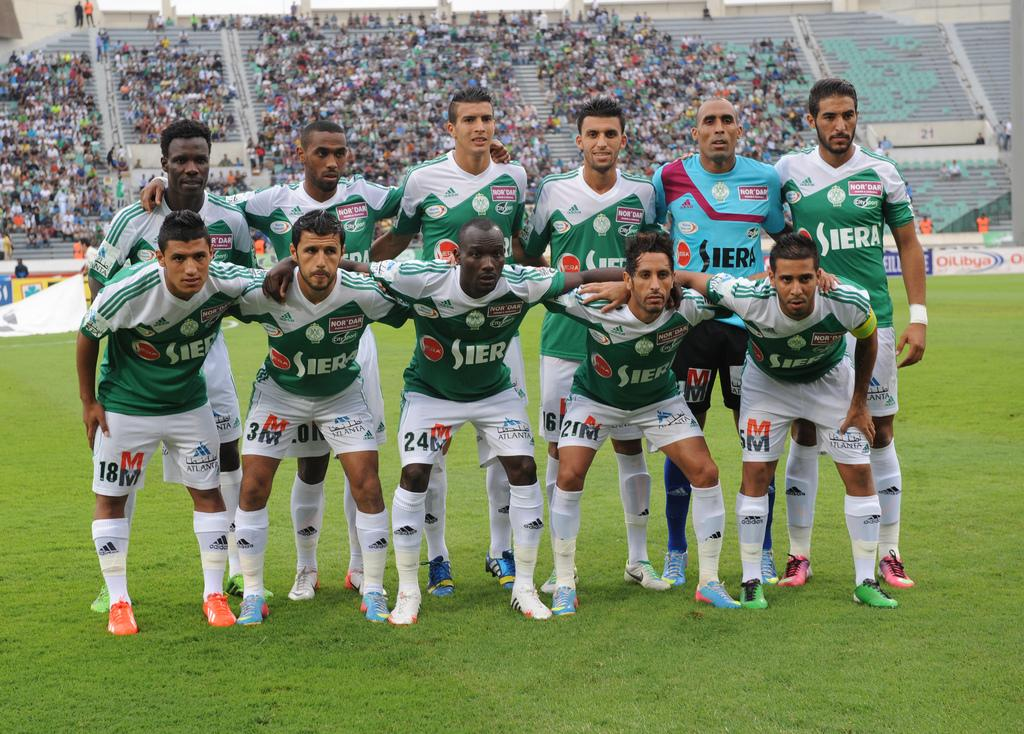<image>
Create a compact narrative representing the image presented. A soccer team stands on a field with green and white jerseys that say SIERA on the front 